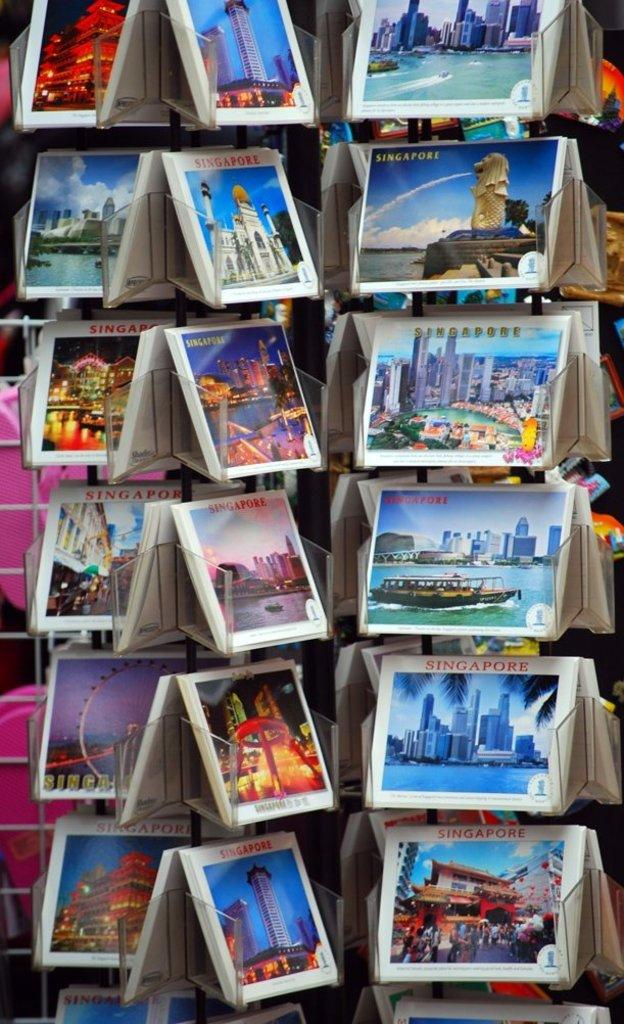What is on the stand in the image? There are books on a stand in the image. What can be seen in the images on the books? The images on the books depict buildings, water, and boats, and there are people visible in these images. What else can be seen in the background of the image? There are objects in the background of the image. What type of eggs are being served at the party in the image? There is no party or eggs present in the image; it features books on a stand with images of buildings, water, and boats. 